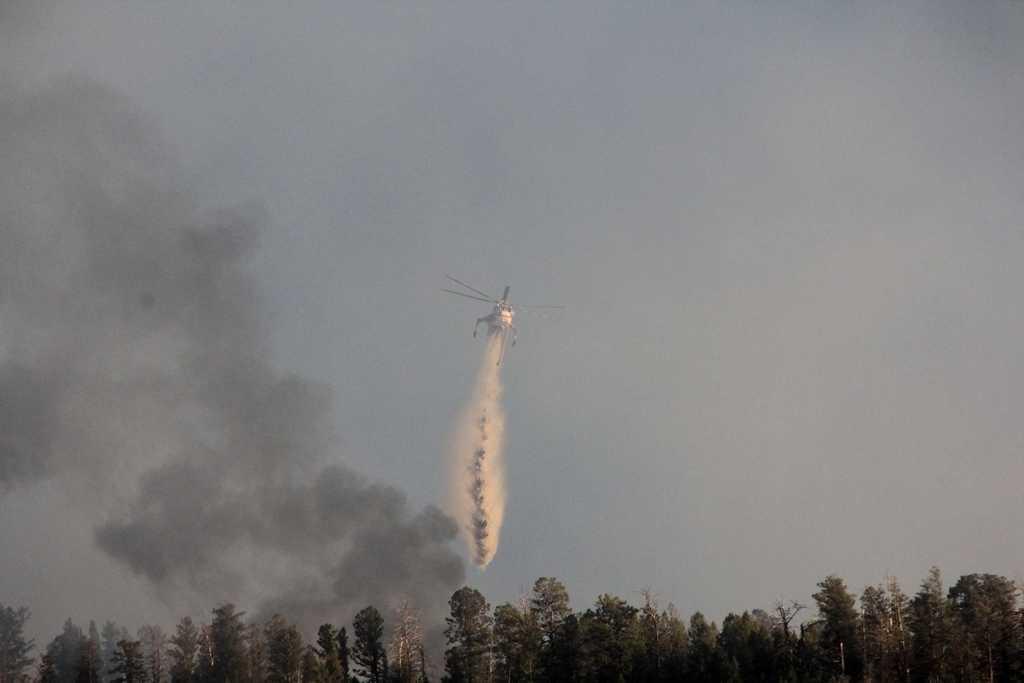Could you give a brief overview of what you see in this image? In the image we can see there is a helicopter flying in the sky and there is smoke in the air. There are lot of trees and there is a clear sky. 